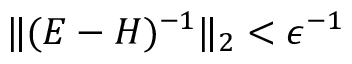<formula> <loc_0><loc_0><loc_500><loc_500>\| ( E - H ) ^ { - 1 } \| _ { 2 } < \epsilon ^ { - 1 }</formula> 